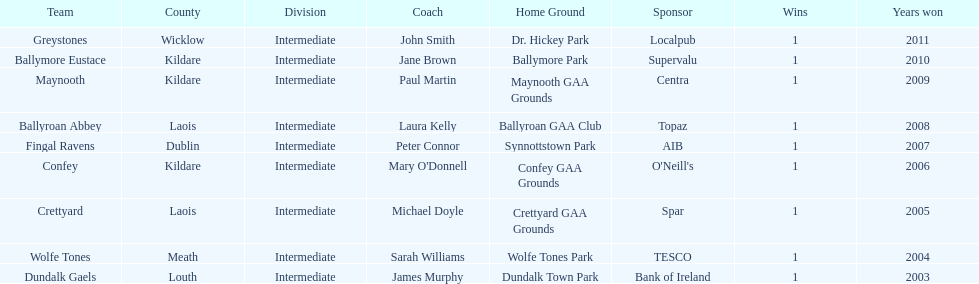What team comes before confey Fingal Ravens. 